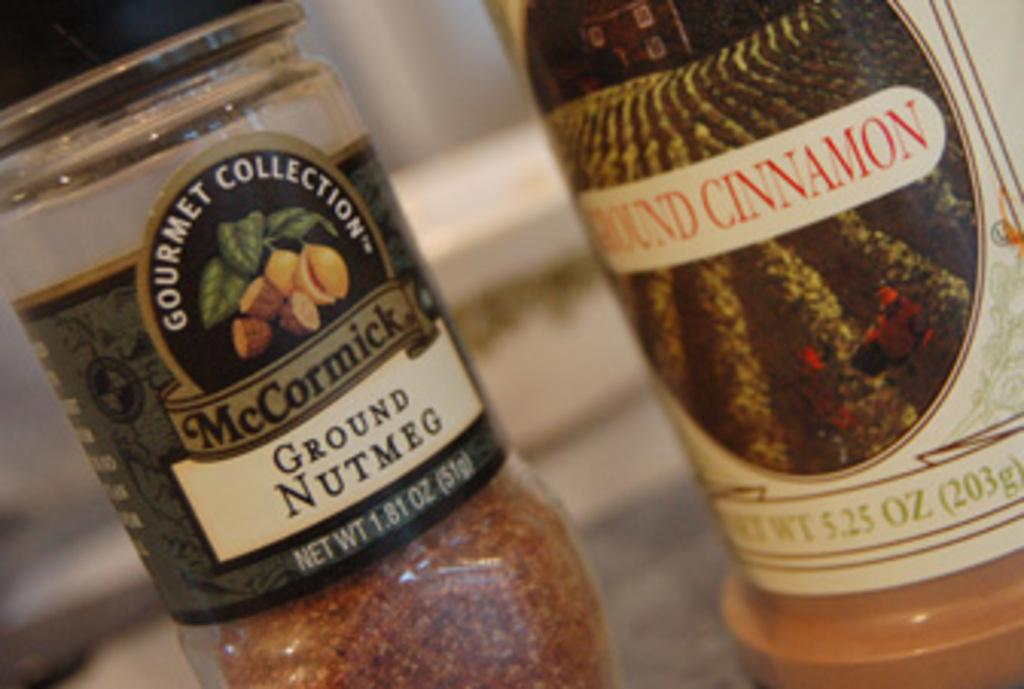<image>
Present a compact description of the photo's key features. A container of Ground Nutmeg is next to a container of Ground Cinnamon. 